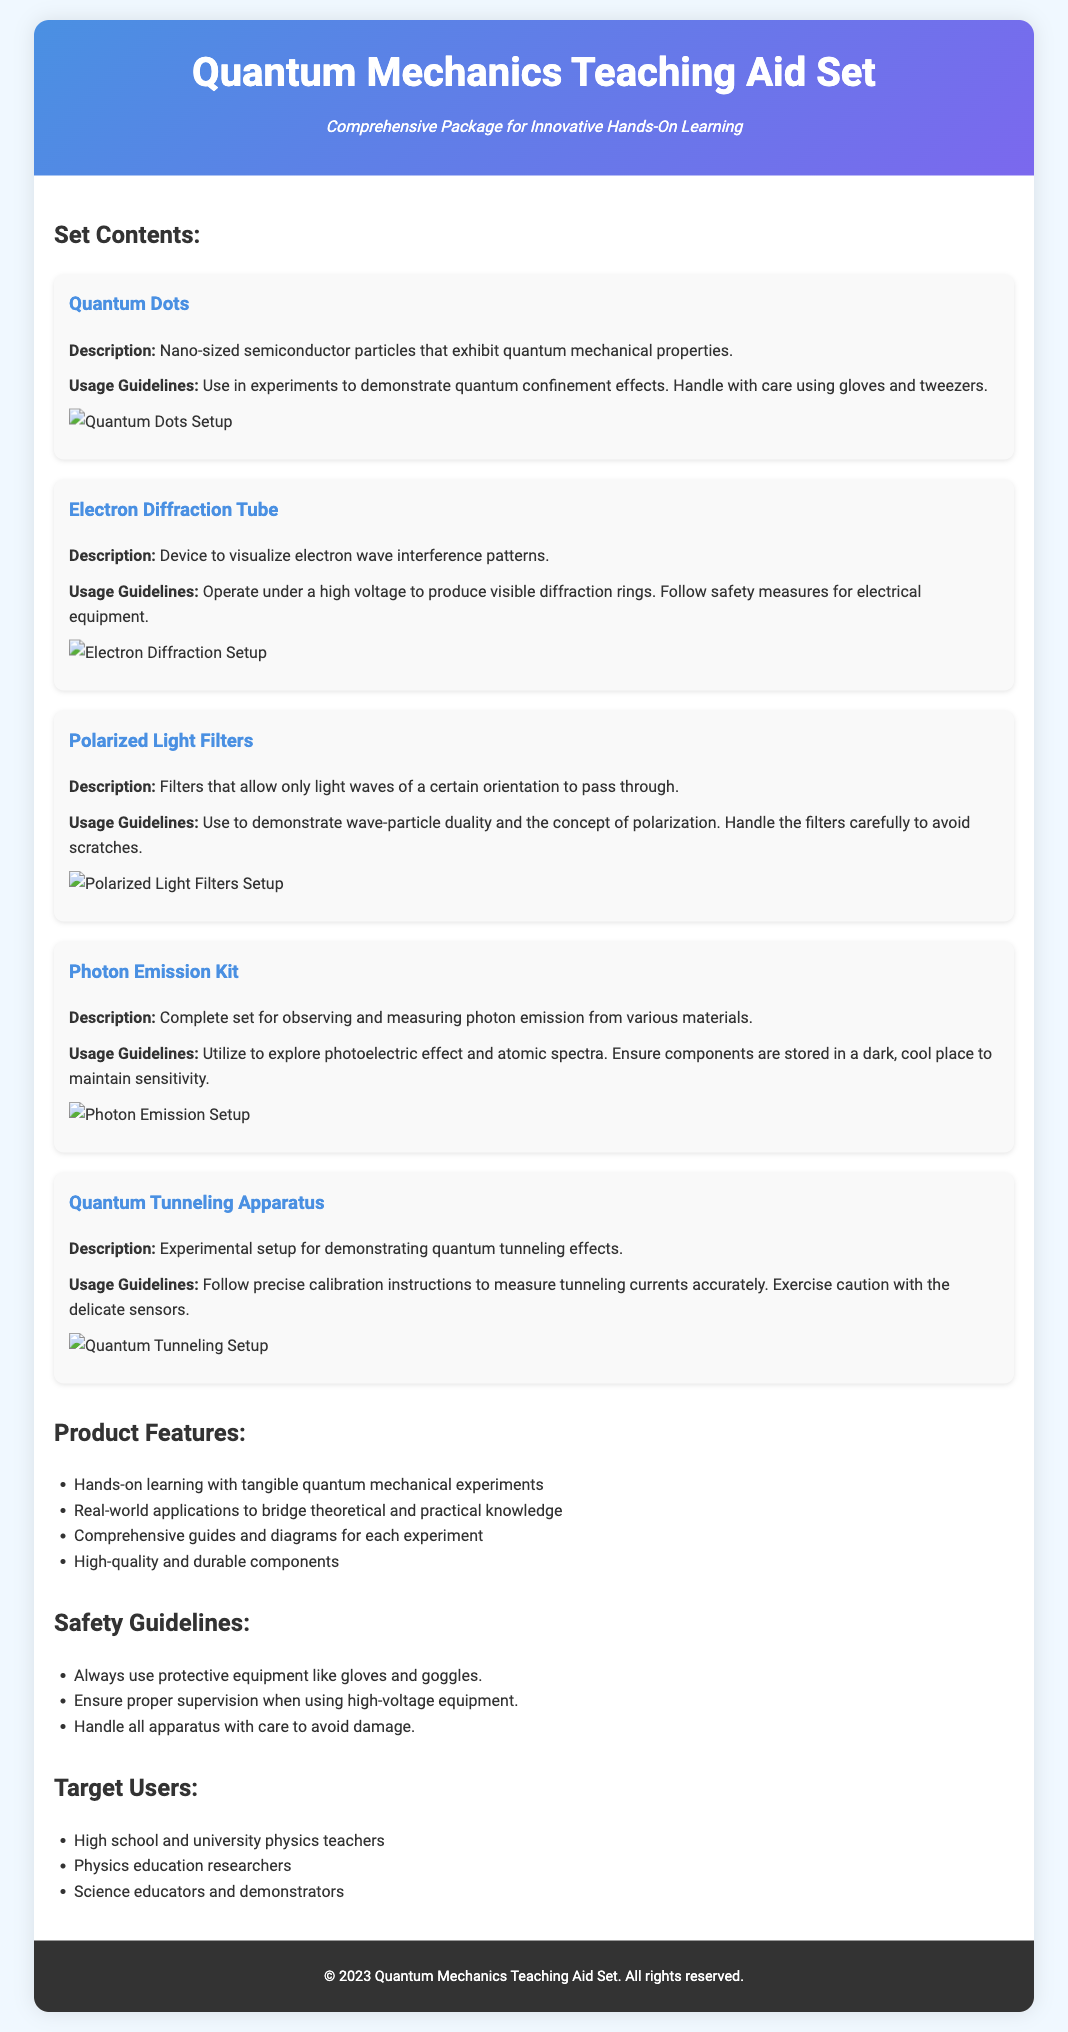what is the title of the document? The title of the document is prominently displayed at the top of the page.
Answer: Quantum Mechanics Teaching Aid Set how many items are listed in the set contents? The document provides information about the various items included in the teaching aid set, specifically counting them.
Answer: Five who is the target user group? The document mentions specific groups that would benefit from the teaching aid set.
Answer: High school and university physics teachers what is the usage guideline for Quantum Dots? Usage guidelines for each item are provided, detailing how to properly use them for experiments.
Answer: Use in experiments to demonstrate quantum confinement effects what safety guideline is stated in the document? Specific precautions are mentioned to ensure safe usage of the equipment included in the set.
Answer: Always use protective equipment like gloves and goggles what type of experiments can the Photon Emission Kit help explore? The document specifies the scientific phenomena that can be investigated using this kit.
Answer: Photoelectric effect and atomic spectra what is the description of the Electron Diffraction Tube? The description gives insight into what this particular item is designed to do in experiments.
Answer: Device to visualize electron wave interference patterns how should polarized light filters be handled? The document provides instructions on the care required for the items in the set.
Answer: Handle the filters carefully to avoid scratches 